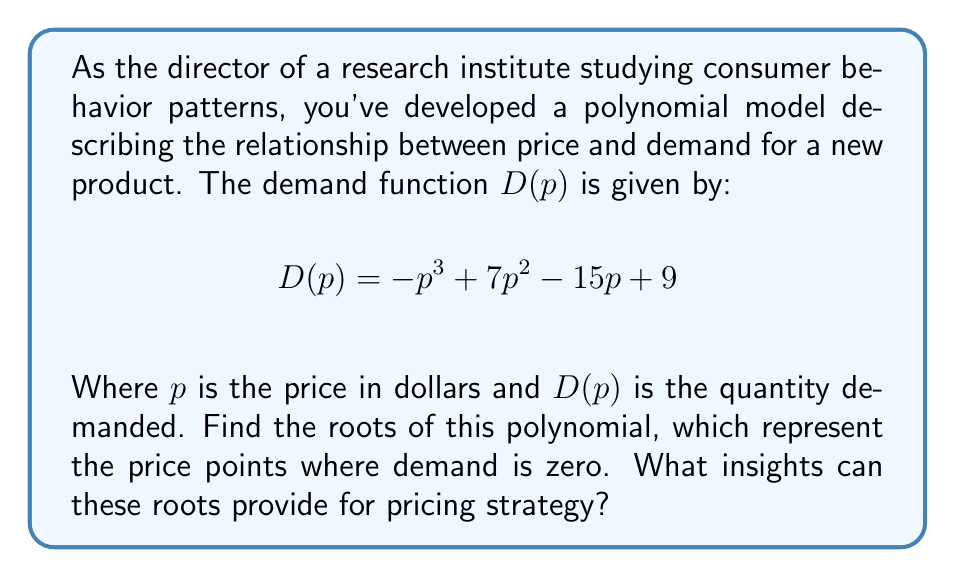Give your solution to this math problem. To find the roots of this polynomial, we need to solve the equation:

$$-p^3 + 7p^2 - 15p + 9 = 0$$

Let's approach this step-by-step:

1) First, we can factor out the greatest common factor (GCF):
   $$-1(p^3 - 7p^2 + 15p - 9) = 0$$

2) The polynomial inside the parentheses is a cubic function. One way to solve this is to guess one root and then use polynomial long division to find the other roots.

3) By inspection or trial and error, we can see that $p = 1$ is a root of this polynomial.

4) Using polynomial long division with $(p - 1)$ as the divisor:

   $$p^3 - 7p^2 + 15p - 9 = (p - 1)(p^2 - 6p + 9)$$

5) The quadratic factor $p^2 - 6p + 9$ can be solved using the quadratic formula or by recognizing it as a perfect square trinomial:

   $$p^2 - 6p + 9 = (p - 3)^2$$

6) Therefore, the complete factorization is:

   $$-1(p - 1)(p - 3)^2 = 0$$

7) The roots of this polynomial are $p = 1$ and $p = 3$ (with multiplicity 2).

Insights for pricing strategy:
- The roots indicate price points where demand is zero.
- $p = 1$ and $p = 3$ are critical price points where demand disappears.
- The double root at $p = 3$ suggests this is a more significant price threshold.
- Prices between $1 and $3 may represent a viable range for positive demand.
- Further analysis of the function between these roots could reveal optimal pricing for maximizing demand or revenue.
Answer: The roots of the polynomial are $p = 1$ and $p = 3$ (with multiplicity 2). 